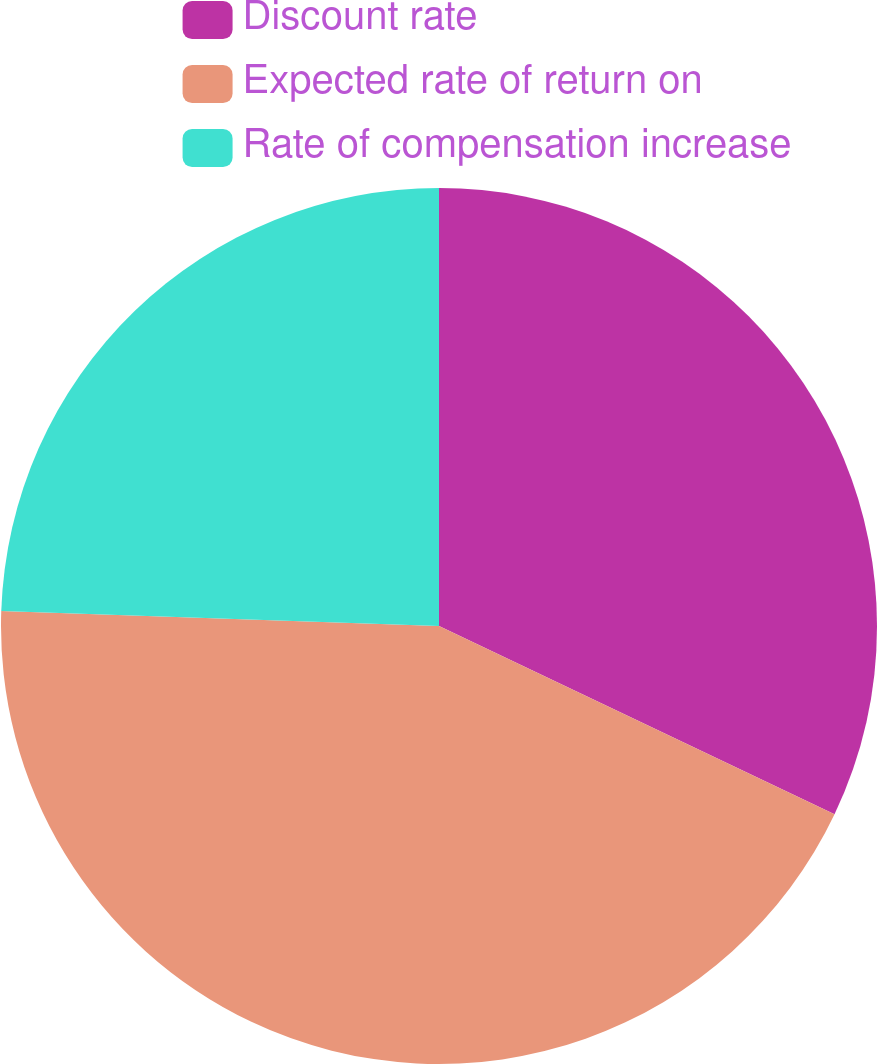<chart> <loc_0><loc_0><loc_500><loc_500><pie_chart><fcel>Discount rate<fcel>Expected rate of return on<fcel>Rate of compensation increase<nl><fcel>32.07%<fcel>43.48%<fcel>24.46%<nl></chart> 